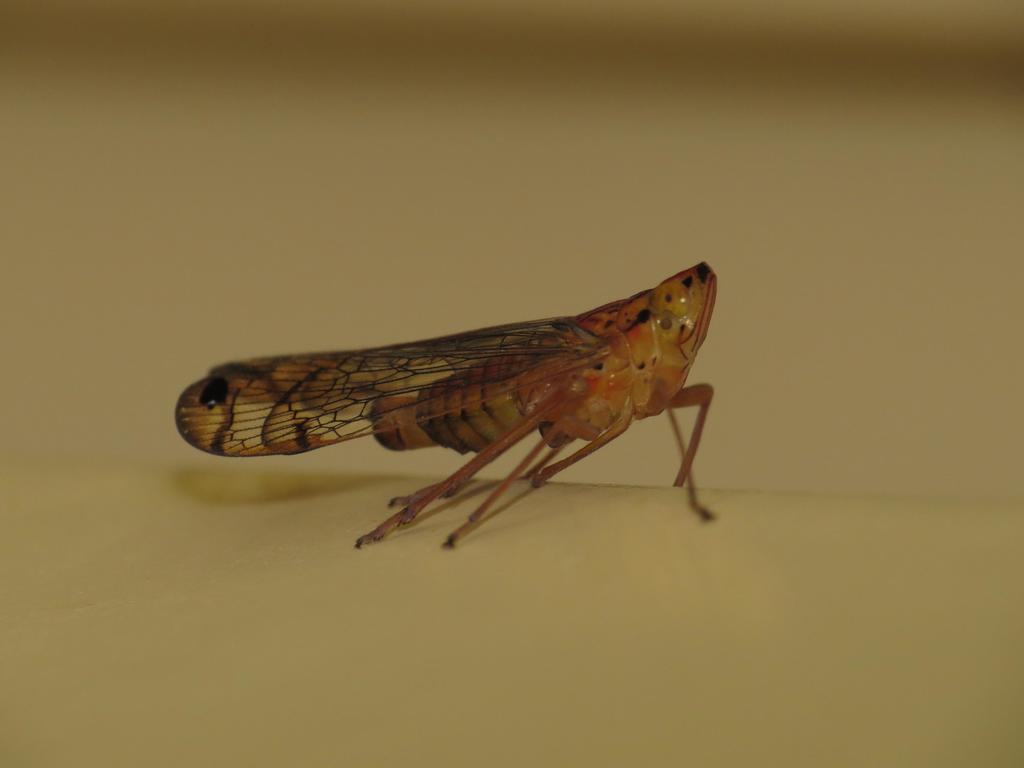What is the main subject of the image? The main subject of the image is a fly. Where is the fly located in the image? The fly is in the center of the image. What type of slope can be seen in the image? There is no slope present in the image; it features a fly in the center. What is the fly using to cook on the stove in the image? There is no stove or cooking activity present in the image; it only features a fly. 